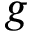Convert formula to latex. <formula><loc_0><loc_0><loc_500><loc_500>{ g }</formula> 